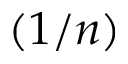Convert formula to latex. <formula><loc_0><loc_0><loc_500><loc_500>( 1 / n )</formula> 